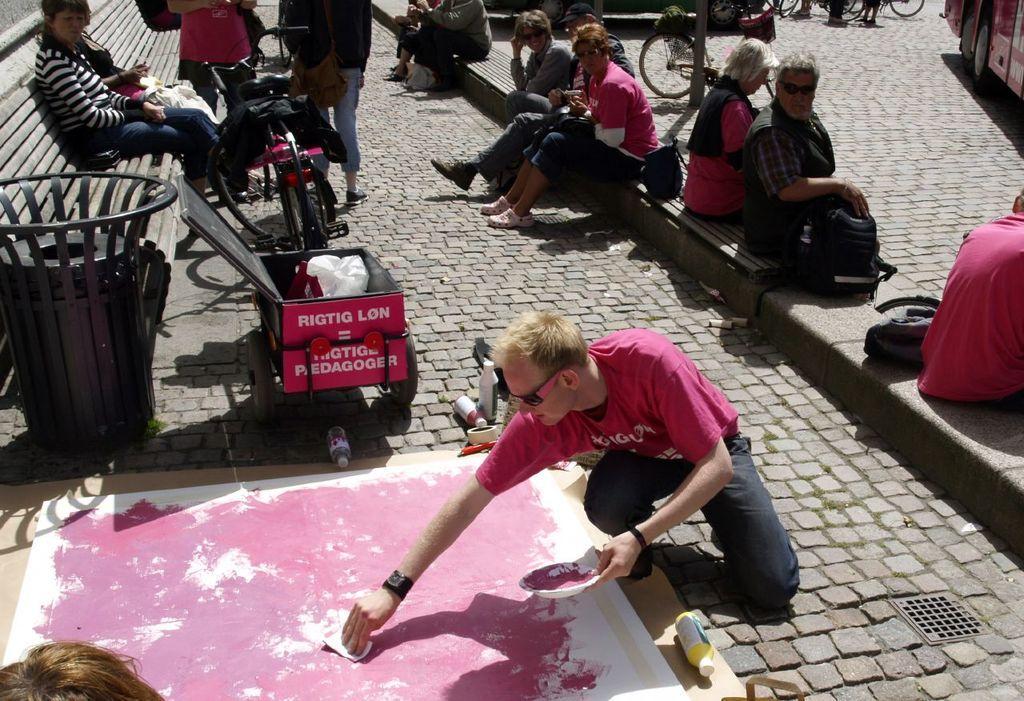In one or two sentences, can you explain what this image depicts? In this picture there is a man wearing a pink color t-shirt, painting the whiteboard which is placed on the cobbler stones. Behind there is a woman sitting on the wooden bench. In the background there is a group of a man and woman sitting and looking to him. 